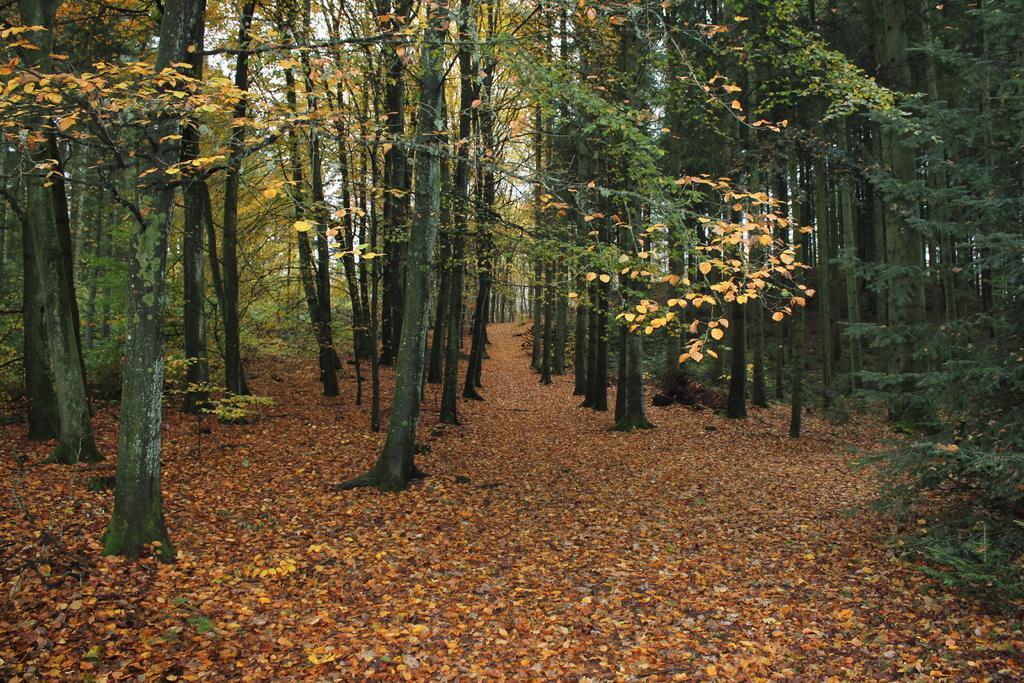How would you summarize this image in a sentence or two? In this picture we can see few trees and leaves on the ground. 